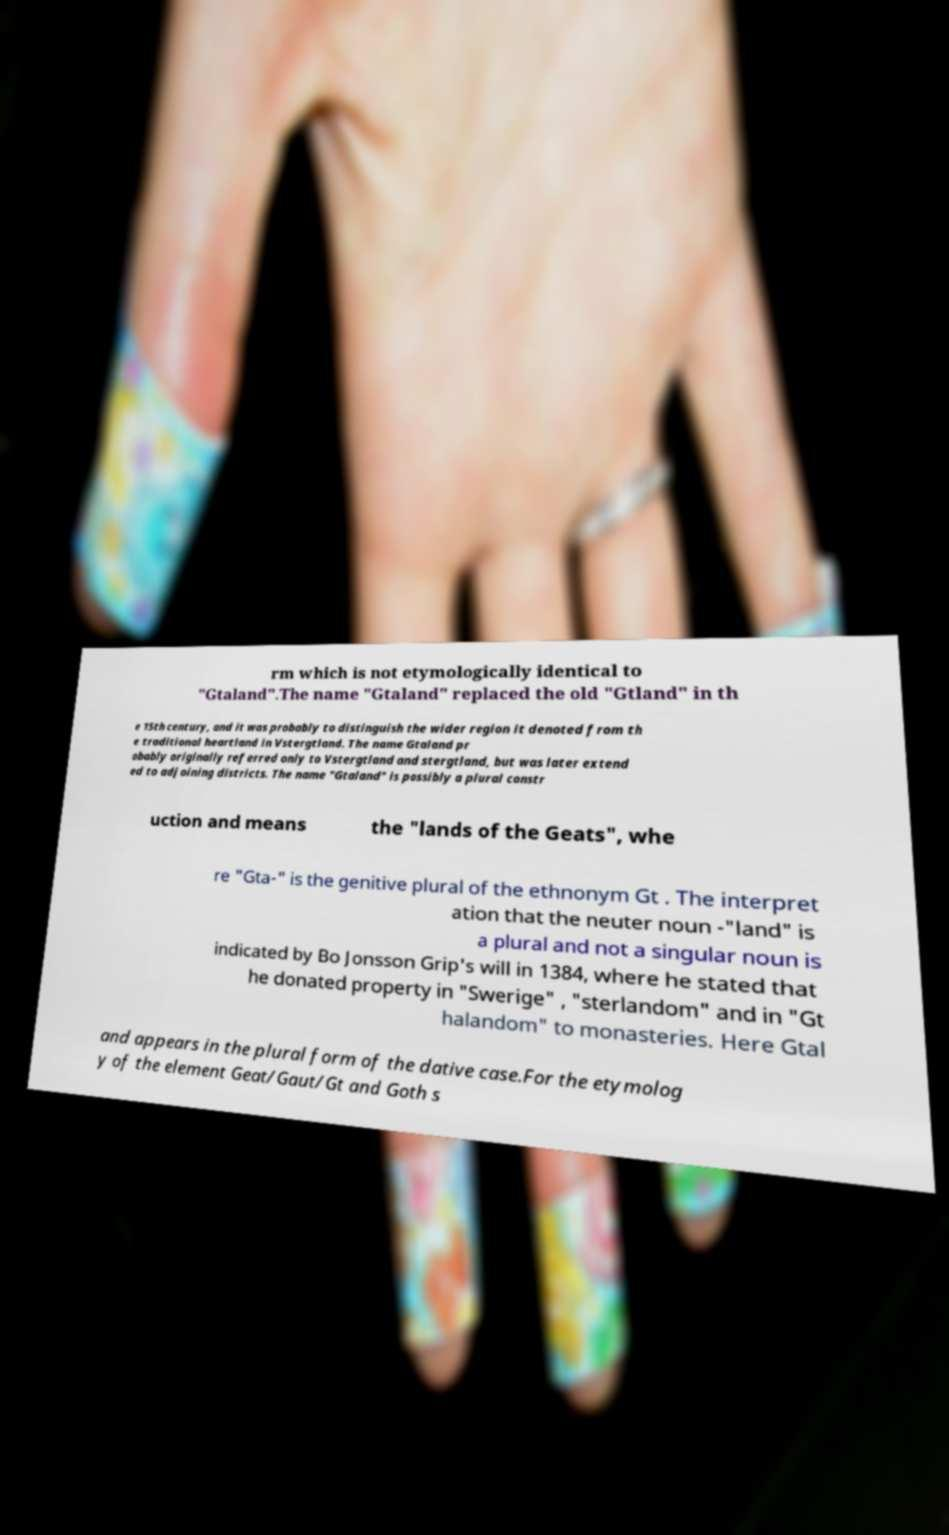Please read and relay the text visible in this image. What does it say? rm which is not etymologically identical to "Gtaland".The name "Gtaland" replaced the old "Gtland" in th e 15th century, and it was probably to distinguish the wider region it denoted from th e traditional heartland in Vstergtland. The name Gtaland pr obably originally referred only to Vstergtland and stergtland, but was later extend ed to adjoining districts. The name "Gtaland" is possibly a plural constr uction and means the "lands of the Geats", whe re "Gta-" is the genitive plural of the ethnonym Gt . The interpret ation that the neuter noun -"land" is a plural and not a singular noun is indicated by Bo Jonsson Grip's will in 1384, where he stated that he donated property in "Swerige" , "sterlandom" and in "Gt halandom" to monasteries. Here Gtal and appears in the plural form of the dative case.For the etymolog y of the element Geat/Gaut/Gt and Goth s 